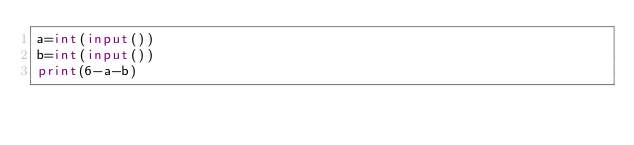Convert code to text. <code><loc_0><loc_0><loc_500><loc_500><_Python_>a=int(input())
b=int(input())
print(6-a-b)</code> 